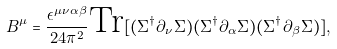Convert formula to latex. <formula><loc_0><loc_0><loc_500><loc_500>B ^ { \mu } = \frac { \epsilon ^ { \mu \nu \alpha \beta } } { 2 4 \pi ^ { 2 } } \text {Tr} [ ( \Sigma ^ { \dag } \partial _ { \nu } \Sigma ) ( \Sigma ^ { \dag } \partial _ { \alpha } \Sigma ) ( \Sigma ^ { \dag } \partial _ { \beta } \Sigma ) ] ,</formula> 